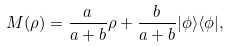<formula> <loc_0><loc_0><loc_500><loc_500>M ( \rho ) = \frac { a } { a + b } \rho + \frac { b } { a + b } | \phi \rangle \langle \phi | ,</formula> 